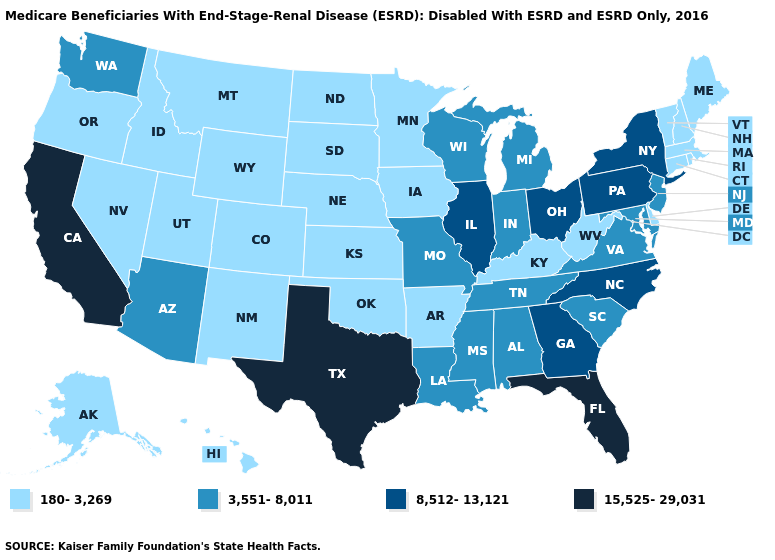What is the highest value in the Northeast ?
Answer briefly. 8,512-13,121. Does Rhode Island have the lowest value in the Northeast?
Be succinct. Yes. How many symbols are there in the legend?
Concise answer only. 4. Name the states that have a value in the range 3,551-8,011?
Quick response, please. Alabama, Arizona, Indiana, Louisiana, Maryland, Michigan, Mississippi, Missouri, New Jersey, South Carolina, Tennessee, Virginia, Washington, Wisconsin. Name the states that have a value in the range 8,512-13,121?
Be succinct. Georgia, Illinois, New York, North Carolina, Ohio, Pennsylvania. Name the states that have a value in the range 3,551-8,011?
Write a very short answer. Alabama, Arizona, Indiana, Louisiana, Maryland, Michigan, Mississippi, Missouri, New Jersey, South Carolina, Tennessee, Virginia, Washington, Wisconsin. Does Oregon have the same value as Colorado?
Concise answer only. Yes. Among the states that border Arizona , which have the lowest value?
Quick response, please. Colorado, Nevada, New Mexico, Utah. What is the value of Hawaii?
Short answer required. 180-3,269. Name the states that have a value in the range 8,512-13,121?
Write a very short answer. Georgia, Illinois, New York, North Carolina, Ohio, Pennsylvania. Name the states that have a value in the range 3,551-8,011?
Answer briefly. Alabama, Arizona, Indiana, Louisiana, Maryland, Michigan, Mississippi, Missouri, New Jersey, South Carolina, Tennessee, Virginia, Washington, Wisconsin. Which states have the lowest value in the MidWest?
Concise answer only. Iowa, Kansas, Minnesota, Nebraska, North Dakota, South Dakota. Name the states that have a value in the range 8,512-13,121?
Keep it brief. Georgia, Illinois, New York, North Carolina, Ohio, Pennsylvania. What is the value of Minnesota?
Be succinct. 180-3,269. 